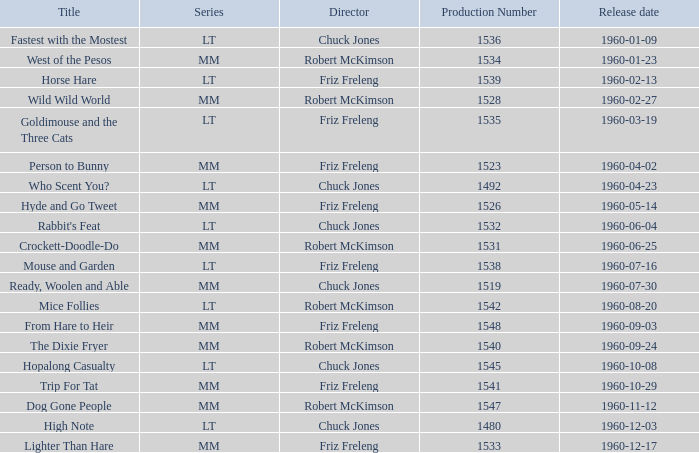What is the episode's series number that has a production number of 1547? MM. 